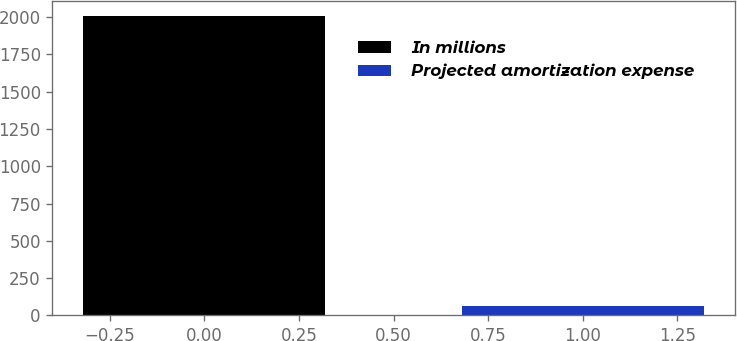Convert chart. <chart><loc_0><loc_0><loc_500><loc_500><bar_chart><fcel>In millions<fcel>Projected amortization expense<nl><fcel>2011<fcel>60<nl></chart> 